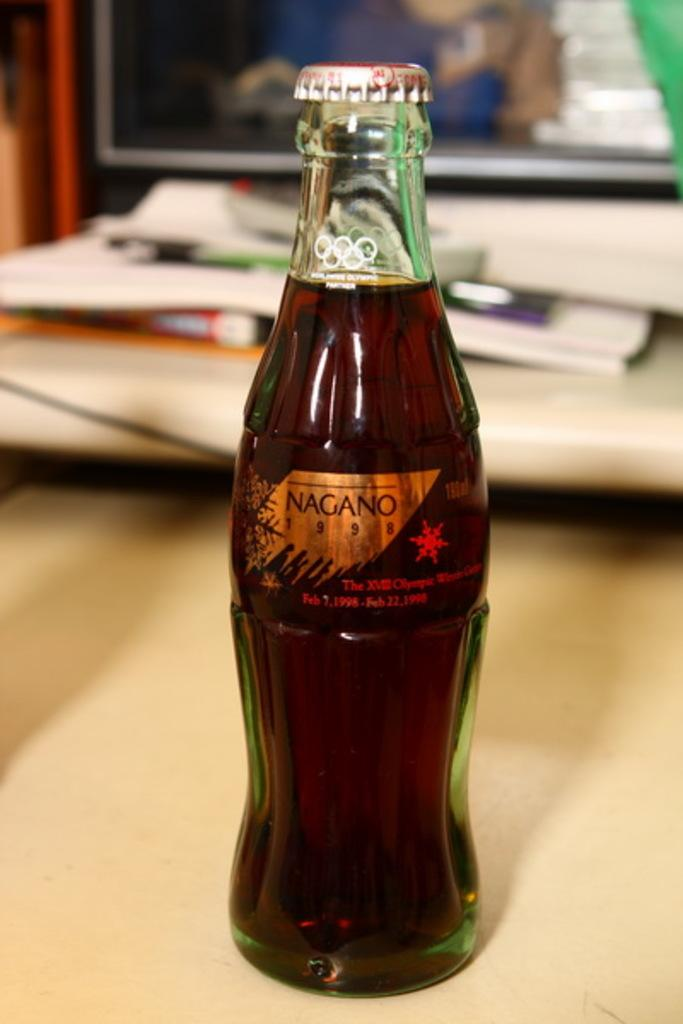Provide a one-sentence caption for the provided image. a NAGANO pop bottle that is unopened. 